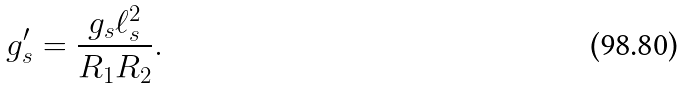<formula> <loc_0><loc_0><loc_500><loc_500>g ^ { \prime } _ { s } = \frac { g _ { s } \ell _ { s } ^ { 2 } } { R _ { 1 } R _ { 2 } } .</formula> 